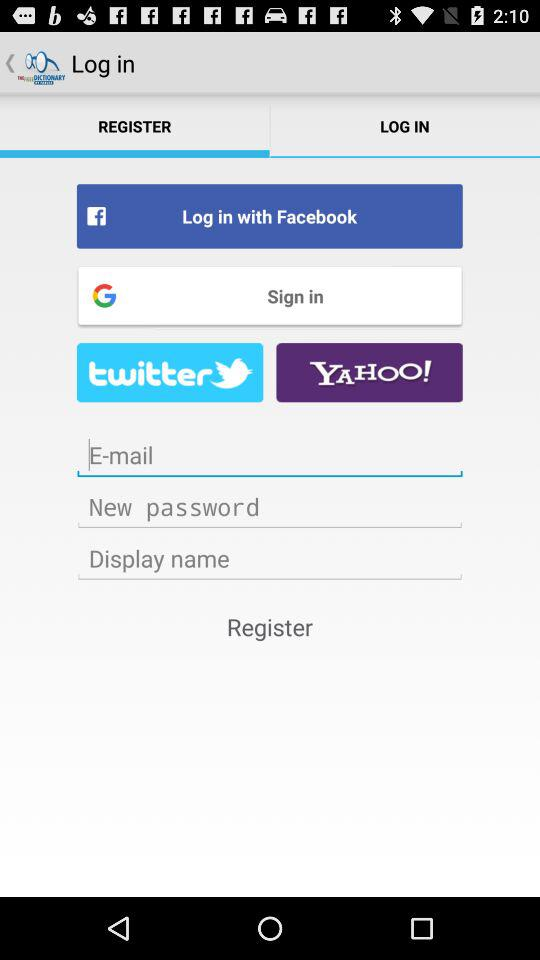Which tab is selected? The selected tab is "REGISTER". 